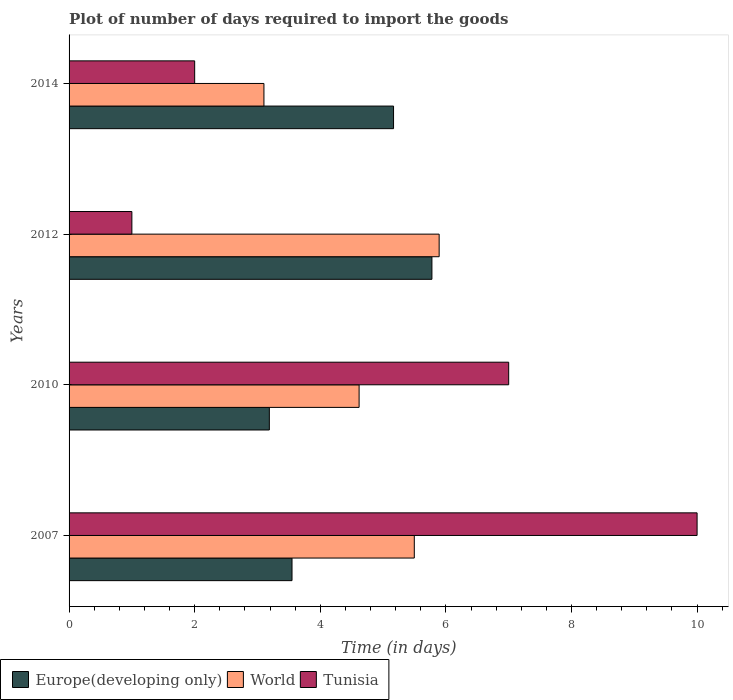Are the number of bars per tick equal to the number of legend labels?
Your answer should be very brief. Yes. How many bars are there on the 4th tick from the bottom?
Your response must be concise. 3. What is the label of the 1st group of bars from the top?
Ensure brevity in your answer.  2014. In how many cases, is the number of bars for a given year not equal to the number of legend labels?
Provide a short and direct response. 0. What is the time required to import goods in World in 2012?
Offer a terse response. 5.89. Across all years, what is the maximum time required to import goods in World?
Your answer should be compact. 5.89. Across all years, what is the minimum time required to import goods in Tunisia?
Your answer should be very brief. 1. In which year was the time required to import goods in World maximum?
Provide a succinct answer. 2012. What is the total time required to import goods in World in the graph?
Offer a very short reply. 19.11. What is the difference between the time required to import goods in World in 2007 and that in 2014?
Your answer should be compact. 2.39. What is the difference between the time required to import goods in Tunisia in 2007 and the time required to import goods in World in 2012?
Give a very brief answer. 4.11. In the year 2010, what is the difference between the time required to import goods in Europe(developing only) and time required to import goods in Tunisia?
Offer a very short reply. -3.81. What is the ratio of the time required to import goods in Europe(developing only) in 2007 to that in 2010?
Provide a short and direct response. 1.11. What is the difference between the highest and the second highest time required to import goods in Europe(developing only)?
Your answer should be compact. 0.61. What is the difference between the highest and the lowest time required to import goods in Tunisia?
Provide a succinct answer. 9. In how many years, is the time required to import goods in Europe(developing only) greater than the average time required to import goods in Europe(developing only) taken over all years?
Ensure brevity in your answer.  2. What does the 3rd bar from the top in 2010 represents?
Your response must be concise. Europe(developing only). What does the 2nd bar from the bottom in 2010 represents?
Your answer should be very brief. World. How many years are there in the graph?
Your answer should be very brief. 4. What is the difference between two consecutive major ticks on the X-axis?
Keep it short and to the point. 2. Are the values on the major ticks of X-axis written in scientific E-notation?
Offer a terse response. No. What is the title of the graph?
Ensure brevity in your answer.  Plot of number of days required to import the goods. What is the label or title of the X-axis?
Give a very brief answer. Time (in days). What is the label or title of the Y-axis?
Offer a terse response. Years. What is the Time (in days) in Europe(developing only) in 2007?
Provide a short and direct response. 3.55. What is the Time (in days) of World in 2007?
Provide a succinct answer. 5.5. What is the Time (in days) of Europe(developing only) in 2010?
Make the answer very short. 3.19. What is the Time (in days) of World in 2010?
Your answer should be very brief. 4.62. What is the Time (in days) of Europe(developing only) in 2012?
Your answer should be compact. 5.78. What is the Time (in days) in World in 2012?
Make the answer very short. 5.89. What is the Time (in days) in Tunisia in 2012?
Keep it short and to the point. 1. What is the Time (in days) of Europe(developing only) in 2014?
Your answer should be very brief. 5.17. What is the Time (in days) of World in 2014?
Offer a very short reply. 3.1. What is the Time (in days) in Tunisia in 2014?
Offer a terse response. 2. Across all years, what is the maximum Time (in days) of Europe(developing only)?
Offer a terse response. 5.78. Across all years, what is the maximum Time (in days) in World?
Make the answer very short. 5.89. Across all years, what is the maximum Time (in days) of Tunisia?
Your answer should be very brief. 10. Across all years, what is the minimum Time (in days) of Europe(developing only)?
Keep it short and to the point. 3.19. Across all years, what is the minimum Time (in days) in World?
Your answer should be very brief. 3.1. Across all years, what is the minimum Time (in days) of Tunisia?
Your answer should be very brief. 1. What is the total Time (in days) in Europe(developing only) in the graph?
Offer a very short reply. 17.68. What is the total Time (in days) in World in the graph?
Offer a terse response. 19.11. What is the difference between the Time (in days) of Europe(developing only) in 2007 and that in 2010?
Give a very brief answer. 0.36. What is the difference between the Time (in days) of World in 2007 and that in 2010?
Ensure brevity in your answer.  0.88. What is the difference between the Time (in days) of Europe(developing only) in 2007 and that in 2012?
Provide a short and direct response. -2.23. What is the difference between the Time (in days) of World in 2007 and that in 2012?
Give a very brief answer. -0.4. What is the difference between the Time (in days) in Tunisia in 2007 and that in 2012?
Your answer should be very brief. 9. What is the difference between the Time (in days) of Europe(developing only) in 2007 and that in 2014?
Give a very brief answer. -1.62. What is the difference between the Time (in days) in World in 2007 and that in 2014?
Give a very brief answer. 2.39. What is the difference between the Time (in days) of Europe(developing only) in 2010 and that in 2012?
Provide a short and direct response. -2.59. What is the difference between the Time (in days) in World in 2010 and that in 2012?
Offer a very short reply. -1.27. What is the difference between the Time (in days) in Europe(developing only) in 2010 and that in 2014?
Provide a succinct answer. -1.98. What is the difference between the Time (in days) of World in 2010 and that in 2014?
Your answer should be very brief. 1.52. What is the difference between the Time (in days) of Europe(developing only) in 2012 and that in 2014?
Your answer should be compact. 0.61. What is the difference between the Time (in days) of World in 2012 and that in 2014?
Provide a short and direct response. 2.79. What is the difference between the Time (in days) in Europe(developing only) in 2007 and the Time (in days) in World in 2010?
Make the answer very short. -1.07. What is the difference between the Time (in days) of Europe(developing only) in 2007 and the Time (in days) of Tunisia in 2010?
Give a very brief answer. -3.45. What is the difference between the Time (in days) of World in 2007 and the Time (in days) of Tunisia in 2010?
Ensure brevity in your answer.  -1.5. What is the difference between the Time (in days) of Europe(developing only) in 2007 and the Time (in days) of World in 2012?
Your answer should be compact. -2.34. What is the difference between the Time (in days) of Europe(developing only) in 2007 and the Time (in days) of Tunisia in 2012?
Give a very brief answer. 2.55. What is the difference between the Time (in days) in World in 2007 and the Time (in days) in Tunisia in 2012?
Offer a very short reply. 4.5. What is the difference between the Time (in days) of Europe(developing only) in 2007 and the Time (in days) of World in 2014?
Keep it short and to the point. 0.45. What is the difference between the Time (in days) of Europe(developing only) in 2007 and the Time (in days) of Tunisia in 2014?
Provide a succinct answer. 1.55. What is the difference between the Time (in days) in World in 2007 and the Time (in days) in Tunisia in 2014?
Provide a succinct answer. 3.5. What is the difference between the Time (in days) in Europe(developing only) in 2010 and the Time (in days) in World in 2012?
Keep it short and to the point. -2.7. What is the difference between the Time (in days) of Europe(developing only) in 2010 and the Time (in days) of Tunisia in 2012?
Make the answer very short. 2.19. What is the difference between the Time (in days) in World in 2010 and the Time (in days) in Tunisia in 2012?
Your answer should be very brief. 3.62. What is the difference between the Time (in days) in Europe(developing only) in 2010 and the Time (in days) in World in 2014?
Your answer should be very brief. 0.09. What is the difference between the Time (in days) in Europe(developing only) in 2010 and the Time (in days) in Tunisia in 2014?
Keep it short and to the point. 1.19. What is the difference between the Time (in days) in World in 2010 and the Time (in days) in Tunisia in 2014?
Give a very brief answer. 2.62. What is the difference between the Time (in days) of Europe(developing only) in 2012 and the Time (in days) of World in 2014?
Make the answer very short. 2.67. What is the difference between the Time (in days) of Europe(developing only) in 2012 and the Time (in days) of Tunisia in 2014?
Offer a terse response. 3.78. What is the difference between the Time (in days) of World in 2012 and the Time (in days) of Tunisia in 2014?
Give a very brief answer. 3.89. What is the average Time (in days) of Europe(developing only) per year?
Ensure brevity in your answer.  4.42. What is the average Time (in days) of World per year?
Ensure brevity in your answer.  4.78. What is the average Time (in days) of Tunisia per year?
Your answer should be compact. 5. In the year 2007, what is the difference between the Time (in days) in Europe(developing only) and Time (in days) in World?
Your answer should be very brief. -1.95. In the year 2007, what is the difference between the Time (in days) in Europe(developing only) and Time (in days) in Tunisia?
Offer a very short reply. -6.45. In the year 2007, what is the difference between the Time (in days) in World and Time (in days) in Tunisia?
Your response must be concise. -4.5. In the year 2010, what is the difference between the Time (in days) in Europe(developing only) and Time (in days) in World?
Your response must be concise. -1.43. In the year 2010, what is the difference between the Time (in days) of Europe(developing only) and Time (in days) of Tunisia?
Give a very brief answer. -3.81. In the year 2010, what is the difference between the Time (in days) of World and Time (in days) of Tunisia?
Offer a terse response. -2.38. In the year 2012, what is the difference between the Time (in days) in Europe(developing only) and Time (in days) in World?
Your answer should be very brief. -0.12. In the year 2012, what is the difference between the Time (in days) of Europe(developing only) and Time (in days) of Tunisia?
Your answer should be very brief. 4.78. In the year 2012, what is the difference between the Time (in days) of World and Time (in days) of Tunisia?
Make the answer very short. 4.89. In the year 2014, what is the difference between the Time (in days) of Europe(developing only) and Time (in days) of World?
Provide a short and direct response. 2.06. In the year 2014, what is the difference between the Time (in days) in Europe(developing only) and Time (in days) in Tunisia?
Your answer should be very brief. 3.17. In the year 2014, what is the difference between the Time (in days) in World and Time (in days) in Tunisia?
Make the answer very short. 1.1. What is the ratio of the Time (in days) of Europe(developing only) in 2007 to that in 2010?
Your answer should be very brief. 1.11. What is the ratio of the Time (in days) of World in 2007 to that in 2010?
Give a very brief answer. 1.19. What is the ratio of the Time (in days) of Tunisia in 2007 to that in 2010?
Your response must be concise. 1.43. What is the ratio of the Time (in days) in Europe(developing only) in 2007 to that in 2012?
Make the answer very short. 0.61. What is the ratio of the Time (in days) in World in 2007 to that in 2012?
Make the answer very short. 0.93. What is the ratio of the Time (in days) of Europe(developing only) in 2007 to that in 2014?
Offer a terse response. 0.69. What is the ratio of the Time (in days) in World in 2007 to that in 2014?
Your answer should be compact. 1.77. What is the ratio of the Time (in days) of Europe(developing only) in 2010 to that in 2012?
Give a very brief answer. 0.55. What is the ratio of the Time (in days) of World in 2010 to that in 2012?
Make the answer very short. 0.78. What is the ratio of the Time (in days) in Tunisia in 2010 to that in 2012?
Ensure brevity in your answer.  7. What is the ratio of the Time (in days) of Europe(developing only) in 2010 to that in 2014?
Provide a succinct answer. 0.62. What is the ratio of the Time (in days) of World in 2010 to that in 2014?
Your answer should be compact. 1.49. What is the ratio of the Time (in days) in Europe(developing only) in 2012 to that in 2014?
Ensure brevity in your answer.  1.12. What is the ratio of the Time (in days) of World in 2012 to that in 2014?
Your answer should be very brief. 1.9. What is the ratio of the Time (in days) of Tunisia in 2012 to that in 2014?
Provide a short and direct response. 0.5. What is the difference between the highest and the second highest Time (in days) in Europe(developing only)?
Your answer should be very brief. 0.61. What is the difference between the highest and the second highest Time (in days) in World?
Your response must be concise. 0.4. What is the difference between the highest and the second highest Time (in days) in Tunisia?
Make the answer very short. 3. What is the difference between the highest and the lowest Time (in days) in Europe(developing only)?
Provide a succinct answer. 2.59. What is the difference between the highest and the lowest Time (in days) in World?
Offer a terse response. 2.79. 